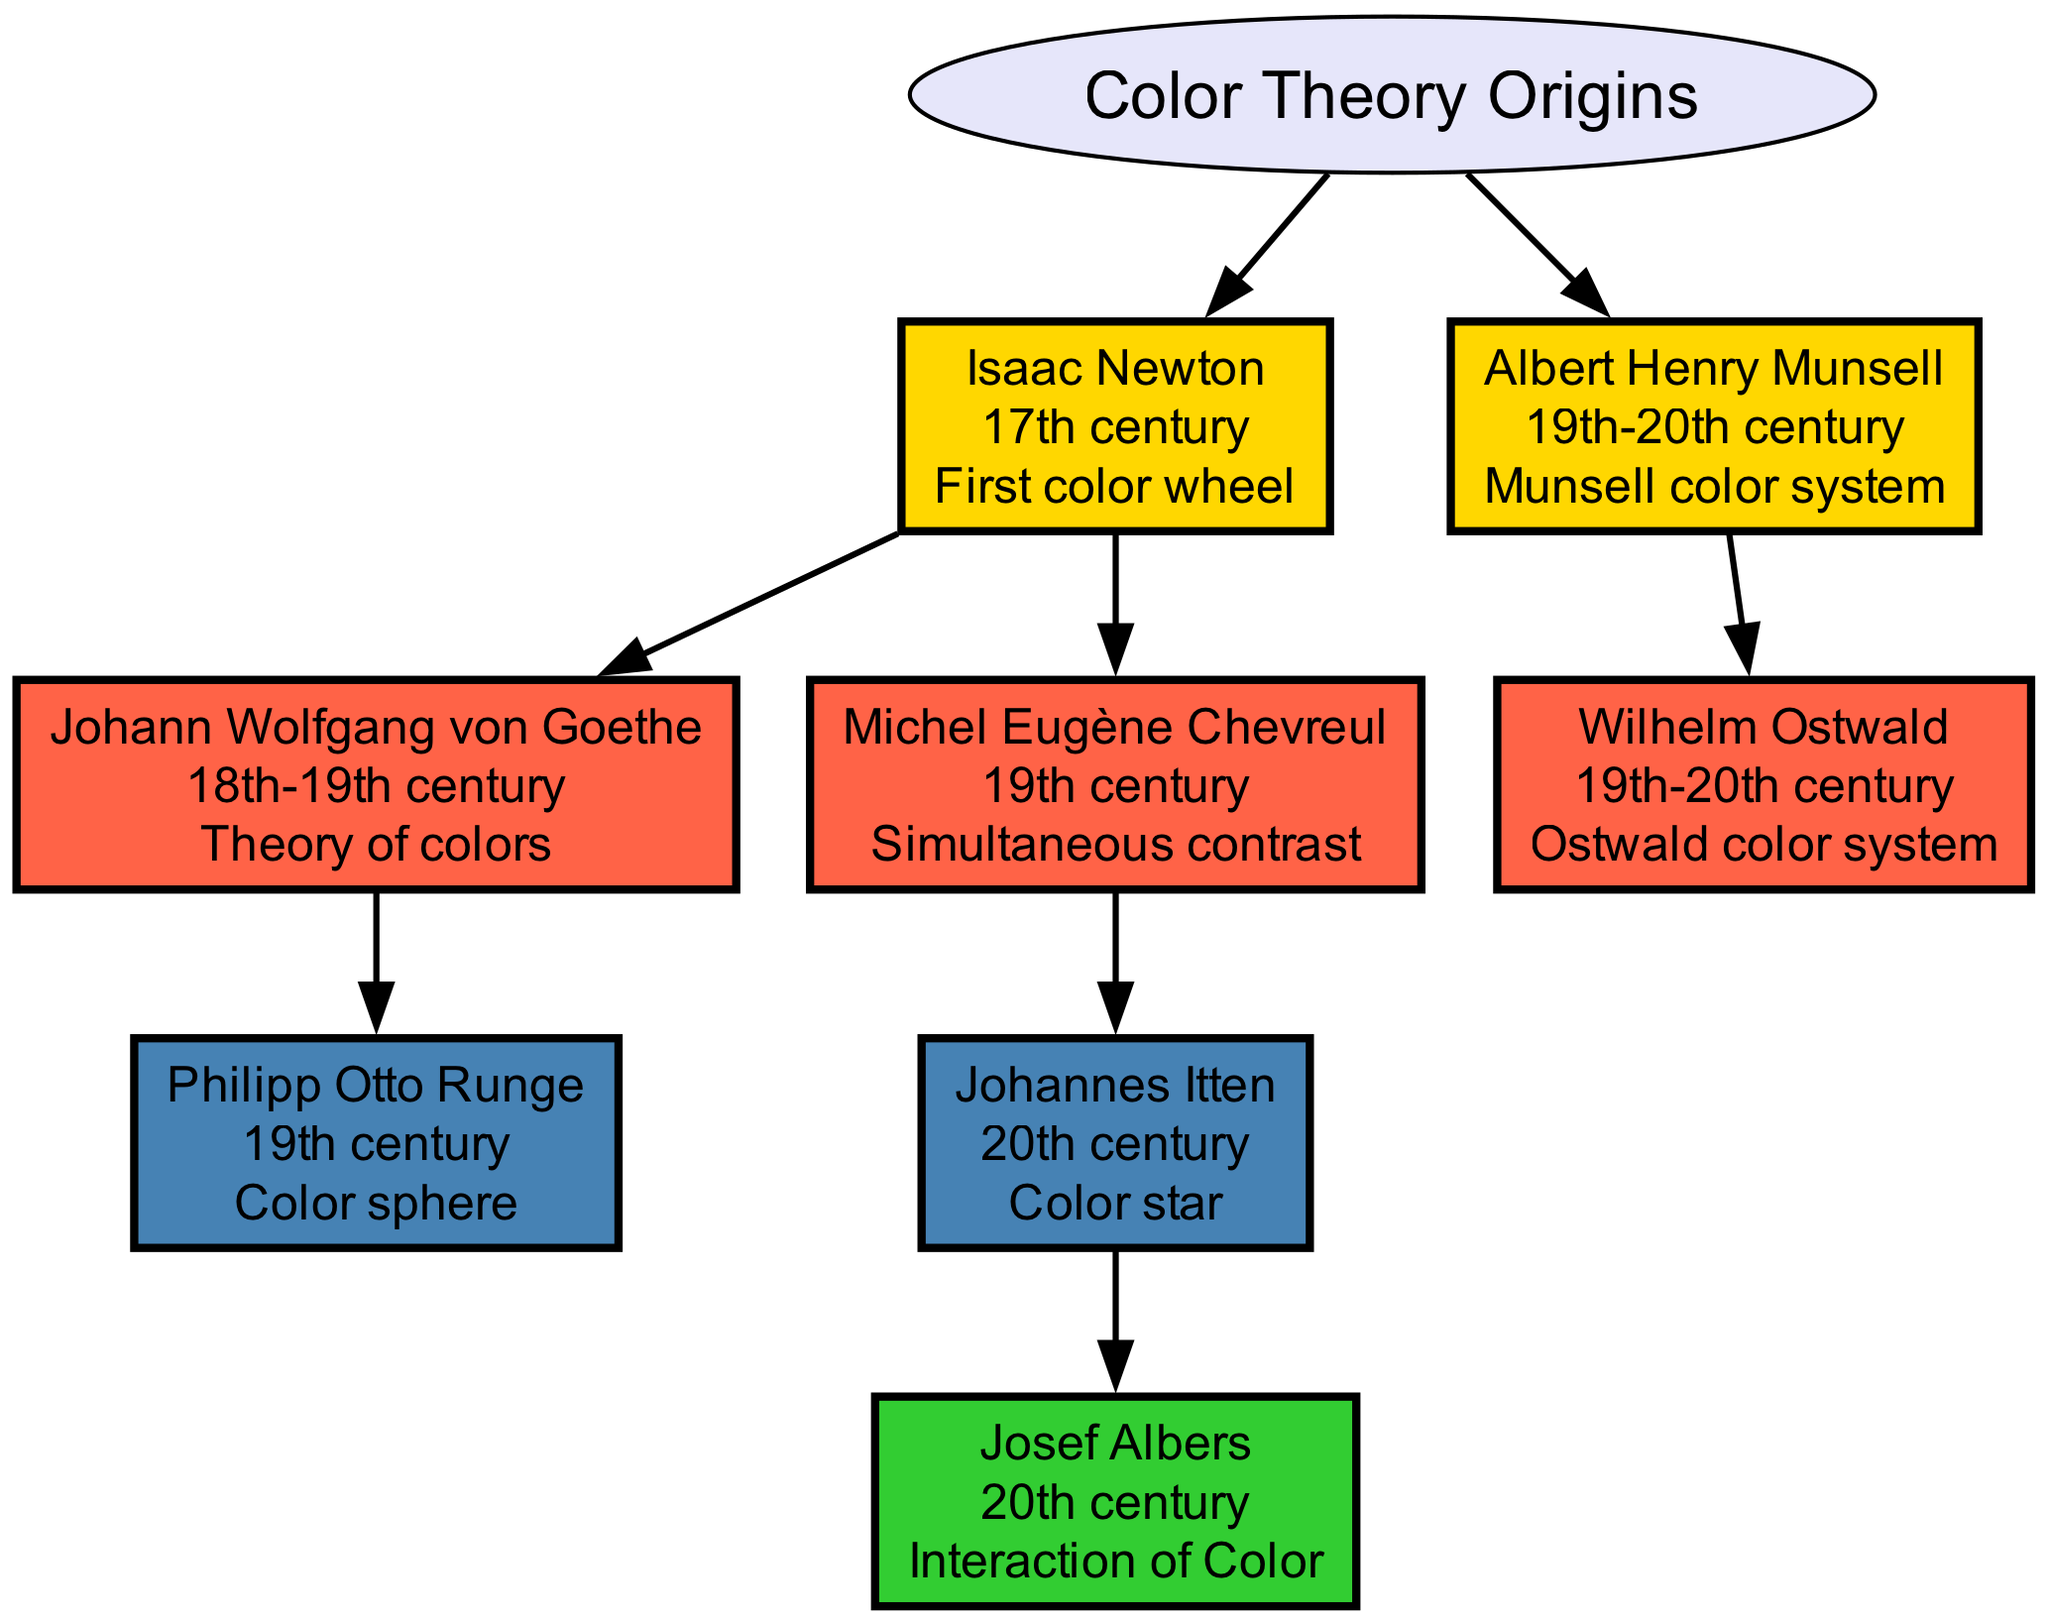What is the contribution of Michel Eugène Chevreul? According to the diagram, Michel Eugène Chevreul's contribution is labeled as "Simultaneous contrast." This information can be found directly under his node.
Answer: Simultaneous contrast Who created the color sphere? The diagram indicates that Philipp Otto Runge is the person who created the color sphere, which is noted in his contribution section under his node.
Answer: Philipp Otto Runge How many children does Isaac Newton have in this diagram? By tracing the branches under Isaac Newton, we can see that he has two children: Johann Wolfgang von Goethe and Michel Eugène Chevreul. Thus, the count of nodes branching from his node is two.
Answer: Two What color theory concept is linked to Johannes Itten? The diagram shows that Johannes Itten's contribution is noted as "Color star." This is directly mentioned in the label of his node.
Answer: Color star Who is the immediate descendant of Michel Eugène Chevreul? The diagram illustrates that Johannes Itten is the immediate descendant of Michel Eugène Chevreul, as he is shown as a child node branching from Chevreul's node.
Answer: Johannes Itten What century did Albert Henry Munsell belong to? According to the information displayed on the diagram, Albert Henry Munsell belonged to the 19th-20th century, as indicated by the label on his node.
Answer: 19th-20th century What is the relationship between Isaac Newton and Johann Wolfgang von Goethe? In the diagram, Johann Wolfgang von Goethe is shown as a child of Isaac Newton, indicating a direct parent-child relationship between the two.
Answer: Parent-child How many total color theory pioneers are represented in this diagram? By counting each node, we identify a total of six pioneers in the color theory genealogy represented in the diagram.
Answer: Six What contribution does Josef Albers make to color theory? The diagram states that Josef Albers's contribution is labeled as "Interaction of Color," which can be found directly associated with his node.
Answer: Interaction of Color 